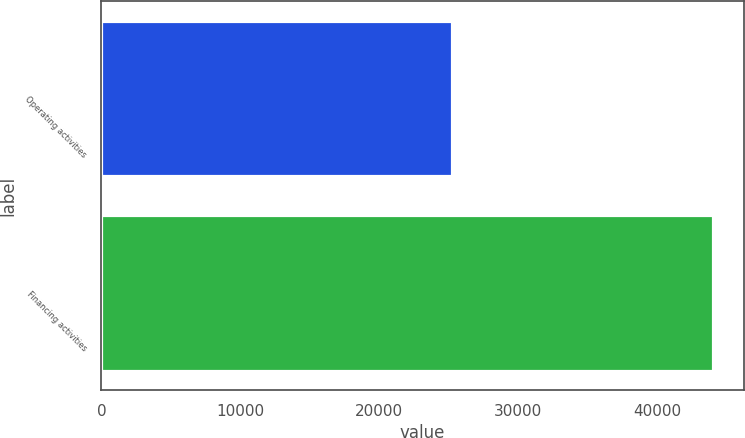Convert chart to OTSL. <chart><loc_0><loc_0><loc_500><loc_500><bar_chart><fcel>Operating activities<fcel>Financing activities<nl><fcel>25261<fcel>44035<nl></chart> 